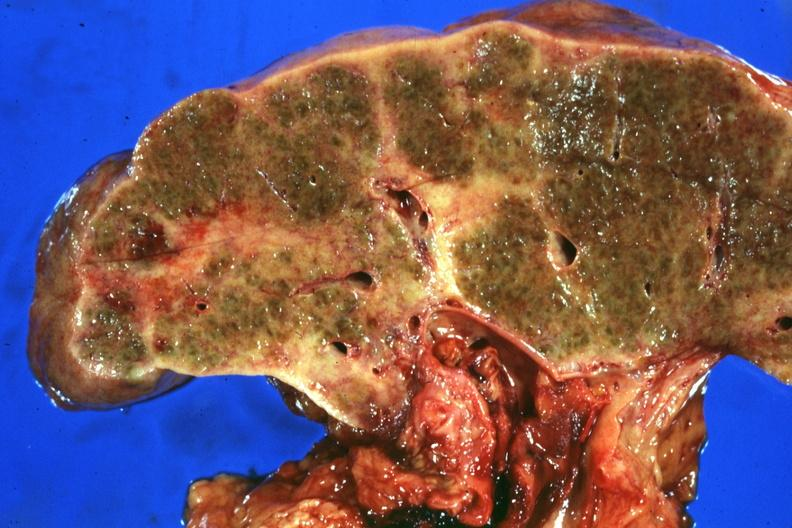s hepatobiliary present?
Answer the question using a single word or phrase. Yes 